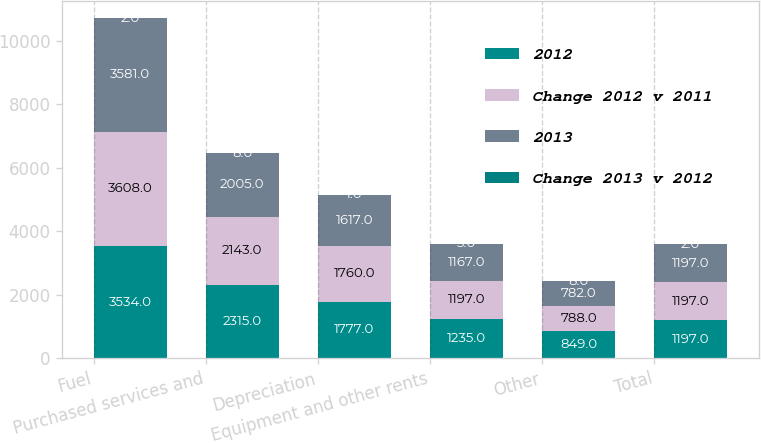<chart> <loc_0><loc_0><loc_500><loc_500><stacked_bar_chart><ecel><fcel>Fuel<fcel>Purchased services and<fcel>Depreciation<fcel>Equipment and other rents<fcel>Other<fcel>Total<nl><fcel>2012<fcel>3534<fcel>2315<fcel>1777<fcel>1235<fcel>849<fcel>1197<nl><fcel>Change 2012 v 2011<fcel>3608<fcel>2143<fcel>1760<fcel>1197<fcel>788<fcel>1197<nl><fcel>2013<fcel>3581<fcel>2005<fcel>1617<fcel>1167<fcel>782<fcel>1197<nl><fcel>Change 2013 v 2012<fcel>2<fcel>8<fcel>1<fcel>3<fcel>8<fcel>2<nl></chart> 